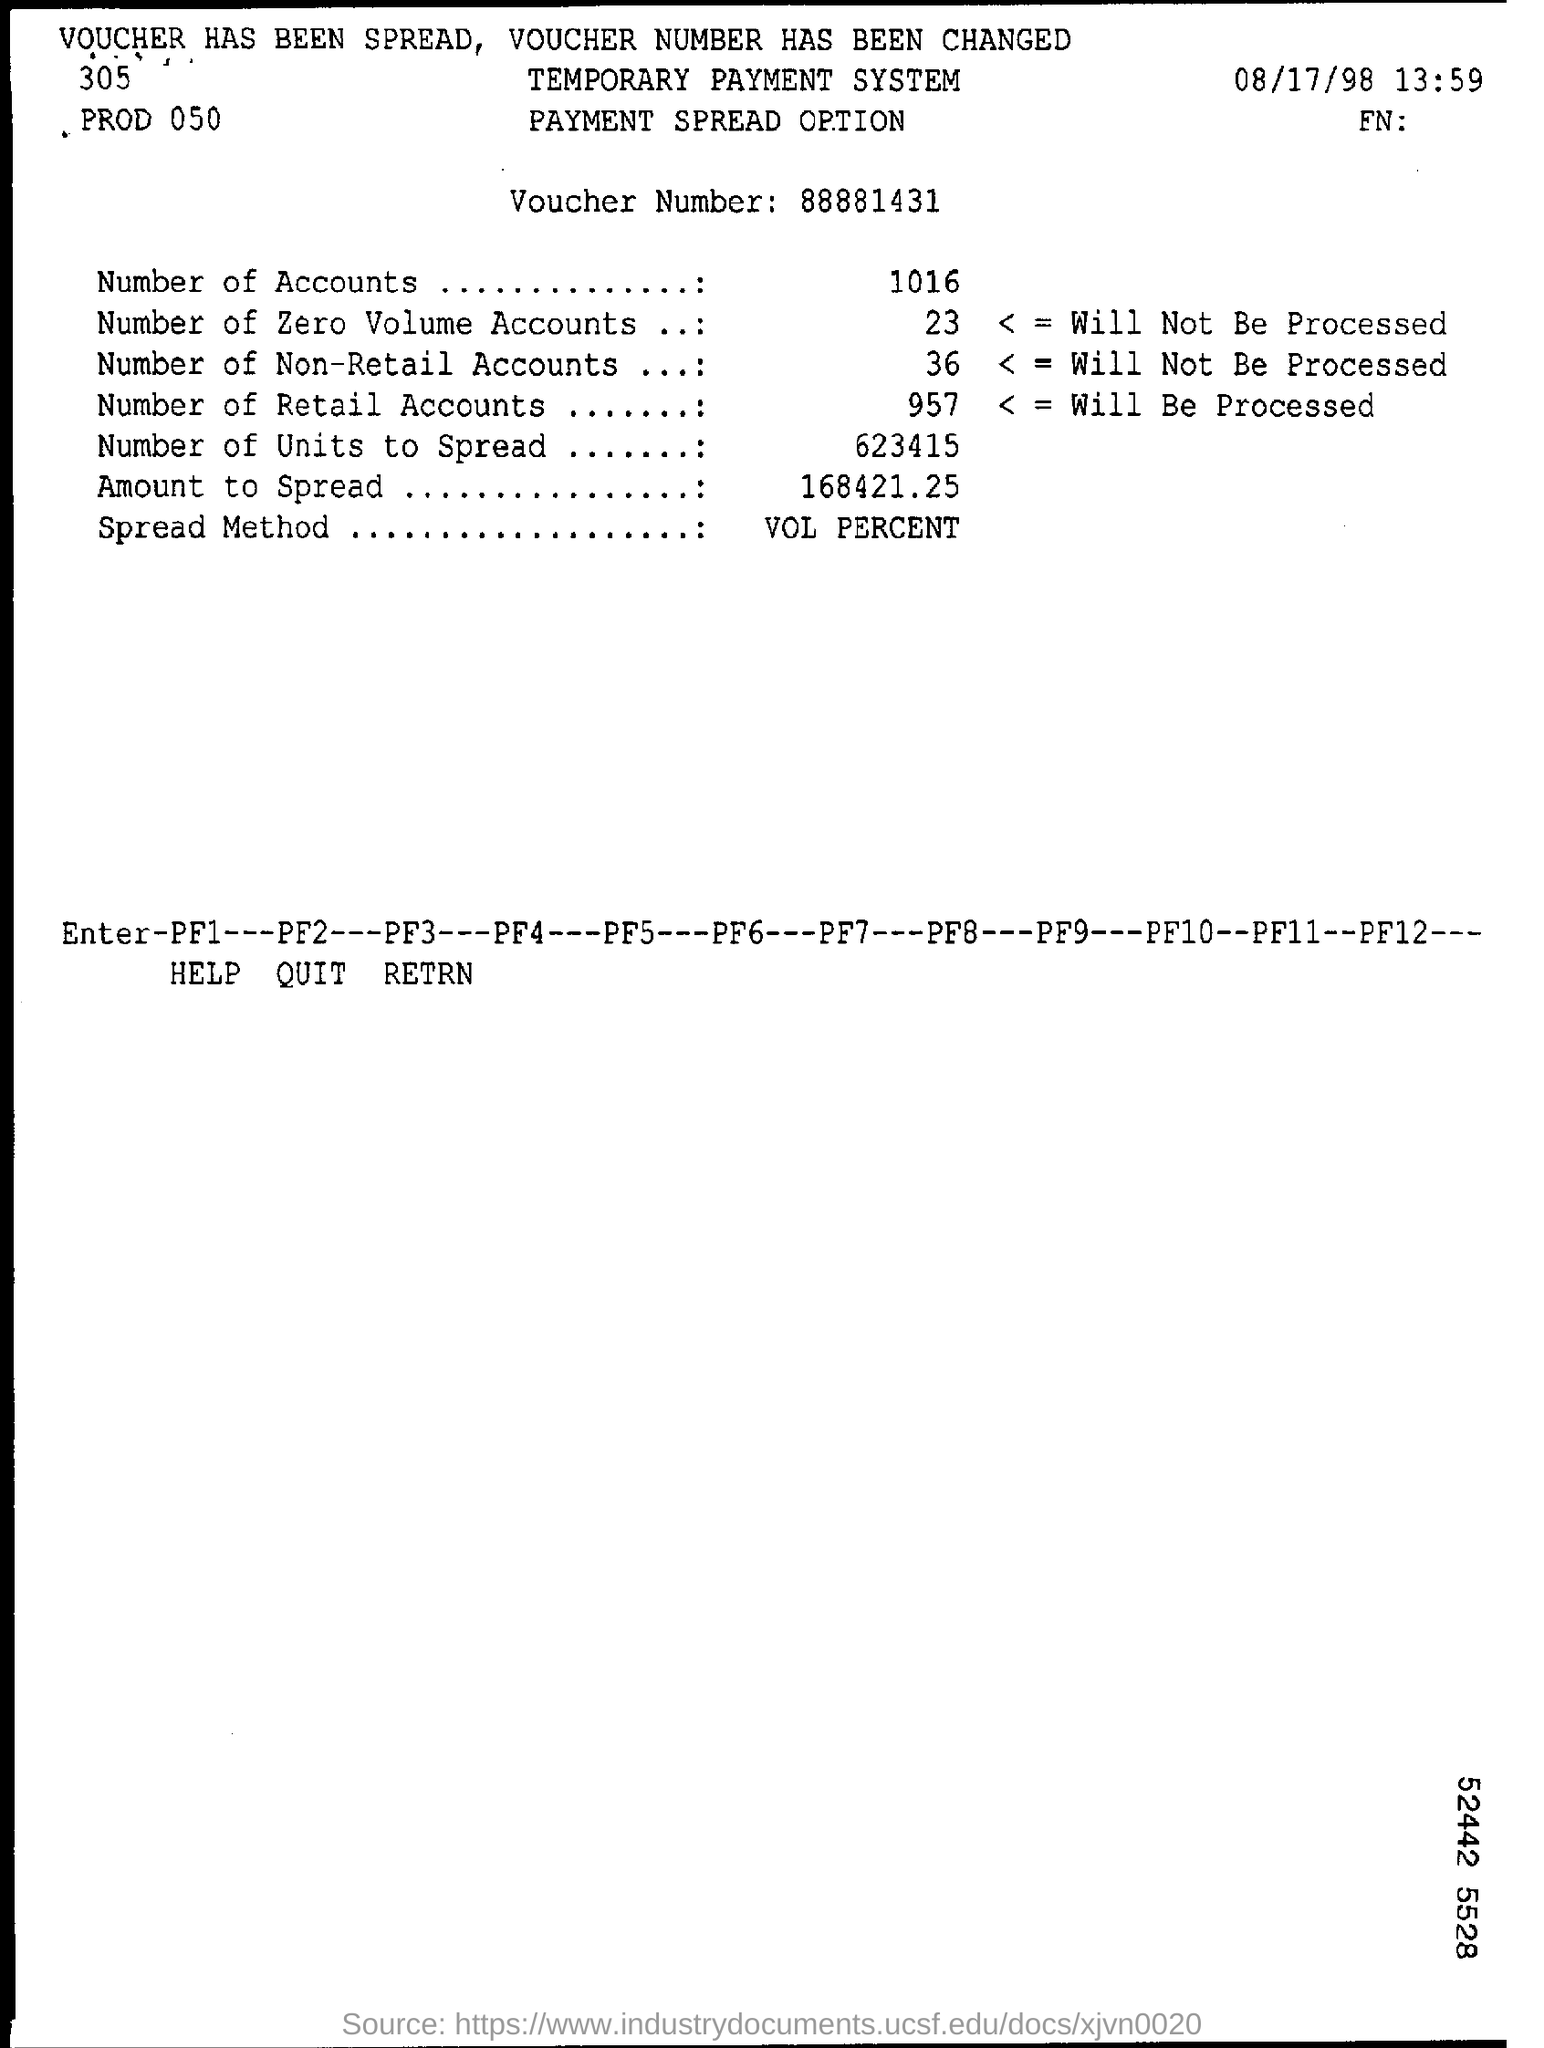What is the voucher number?
Provide a short and direct response. 88881431. How many accounts are mentioned?
Your response must be concise. 1016. What is the spread method?
Offer a terse response. Vol percent. What is the date mentioned?
Ensure brevity in your answer.  08/17/98. 